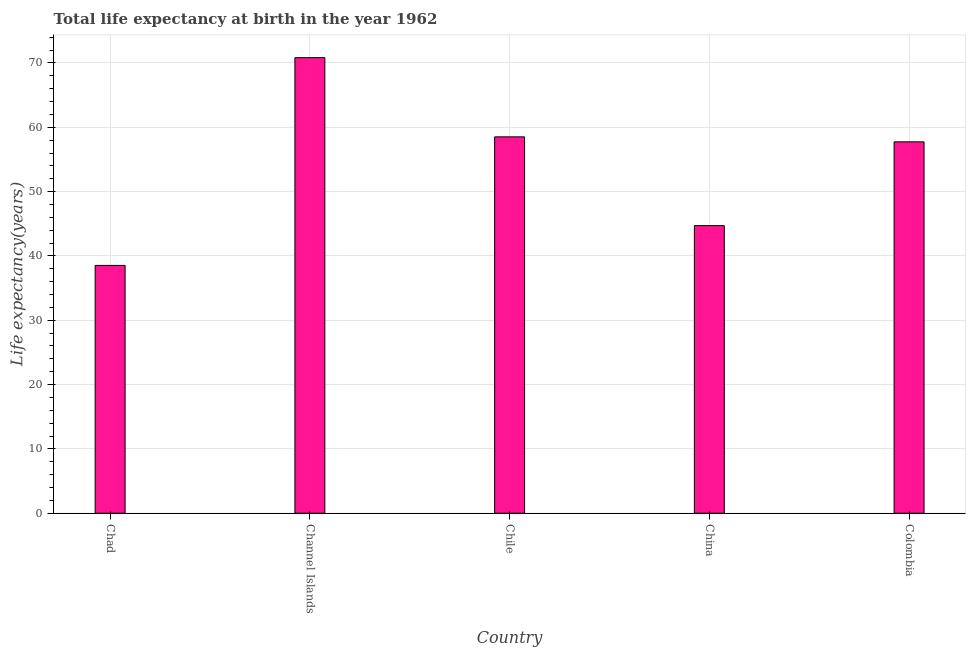Does the graph contain any zero values?
Make the answer very short. No. What is the title of the graph?
Your answer should be very brief. Total life expectancy at birth in the year 1962. What is the label or title of the X-axis?
Give a very brief answer. Country. What is the label or title of the Y-axis?
Your answer should be very brief. Life expectancy(years). What is the life expectancy at birth in Colombia?
Make the answer very short. 57.74. Across all countries, what is the maximum life expectancy at birth?
Give a very brief answer. 70.83. Across all countries, what is the minimum life expectancy at birth?
Your answer should be very brief. 38.53. In which country was the life expectancy at birth maximum?
Your response must be concise. Channel Islands. In which country was the life expectancy at birth minimum?
Your answer should be very brief. Chad. What is the sum of the life expectancy at birth?
Give a very brief answer. 270.33. What is the difference between the life expectancy at birth in Chad and Chile?
Provide a short and direct response. -19.99. What is the average life expectancy at birth per country?
Keep it short and to the point. 54.06. What is the median life expectancy at birth?
Your response must be concise. 57.74. What is the ratio of the life expectancy at birth in Channel Islands to that in Colombia?
Provide a succinct answer. 1.23. Is the difference between the life expectancy at birth in Chad and China greater than the difference between any two countries?
Offer a very short reply. No. What is the difference between the highest and the second highest life expectancy at birth?
Your answer should be very brief. 12.31. Is the sum of the life expectancy at birth in Chad and China greater than the maximum life expectancy at birth across all countries?
Offer a very short reply. Yes. What is the difference between the highest and the lowest life expectancy at birth?
Your response must be concise. 32.3. How many bars are there?
Give a very brief answer. 5. What is the difference between two consecutive major ticks on the Y-axis?
Provide a succinct answer. 10. What is the Life expectancy(years) of Chad?
Offer a very short reply. 38.53. What is the Life expectancy(years) in Channel Islands?
Offer a very short reply. 70.83. What is the Life expectancy(years) of Chile?
Make the answer very short. 58.52. What is the Life expectancy(years) in China?
Your answer should be very brief. 44.71. What is the Life expectancy(years) of Colombia?
Your response must be concise. 57.74. What is the difference between the Life expectancy(years) in Chad and Channel Islands?
Offer a very short reply. -32.3. What is the difference between the Life expectancy(years) in Chad and Chile?
Make the answer very short. -19.99. What is the difference between the Life expectancy(years) in Chad and China?
Make the answer very short. -6.18. What is the difference between the Life expectancy(years) in Chad and Colombia?
Provide a short and direct response. -19.21. What is the difference between the Life expectancy(years) in Channel Islands and Chile?
Your answer should be compact. 12.31. What is the difference between the Life expectancy(years) in Channel Islands and China?
Your response must be concise. 26.12. What is the difference between the Life expectancy(years) in Channel Islands and Colombia?
Provide a succinct answer. 13.09. What is the difference between the Life expectancy(years) in Chile and China?
Offer a terse response. 13.8. What is the difference between the Life expectancy(years) in Chile and Colombia?
Provide a short and direct response. 0.78. What is the difference between the Life expectancy(years) in China and Colombia?
Your response must be concise. -13.03. What is the ratio of the Life expectancy(years) in Chad to that in Channel Islands?
Keep it short and to the point. 0.54. What is the ratio of the Life expectancy(years) in Chad to that in Chile?
Your answer should be compact. 0.66. What is the ratio of the Life expectancy(years) in Chad to that in China?
Make the answer very short. 0.86. What is the ratio of the Life expectancy(years) in Chad to that in Colombia?
Your answer should be very brief. 0.67. What is the ratio of the Life expectancy(years) in Channel Islands to that in Chile?
Your answer should be very brief. 1.21. What is the ratio of the Life expectancy(years) in Channel Islands to that in China?
Make the answer very short. 1.58. What is the ratio of the Life expectancy(years) in Channel Islands to that in Colombia?
Give a very brief answer. 1.23. What is the ratio of the Life expectancy(years) in Chile to that in China?
Offer a terse response. 1.31. What is the ratio of the Life expectancy(years) in China to that in Colombia?
Offer a very short reply. 0.77. 